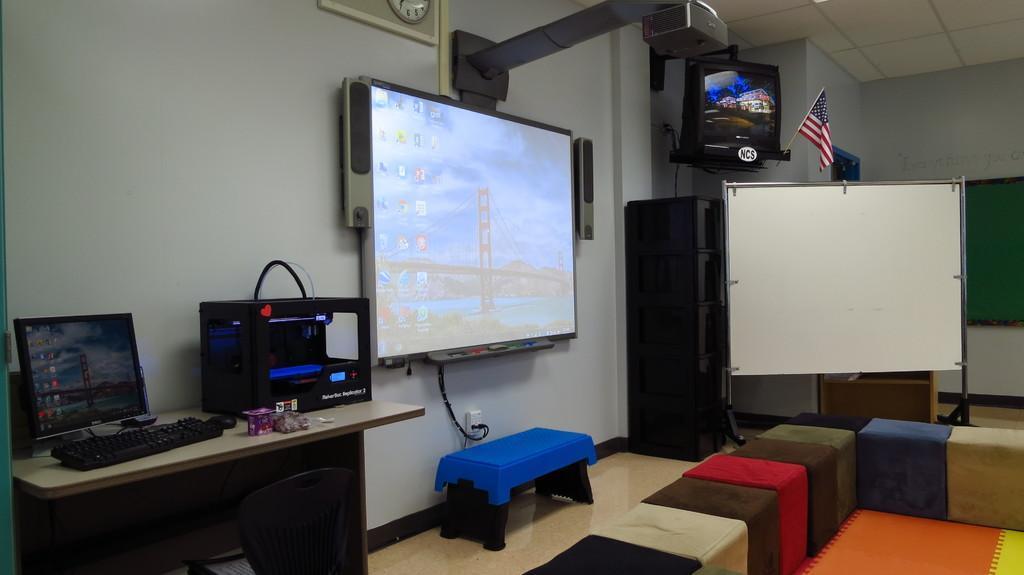Could you give a brief overview of what you see in this image? In the image we can see the television, system, keyboard, mouse and other electronic device. Here we can see the stool, white board and the clock. Here we can see the flag of the country, floor, carpet and the wall. 